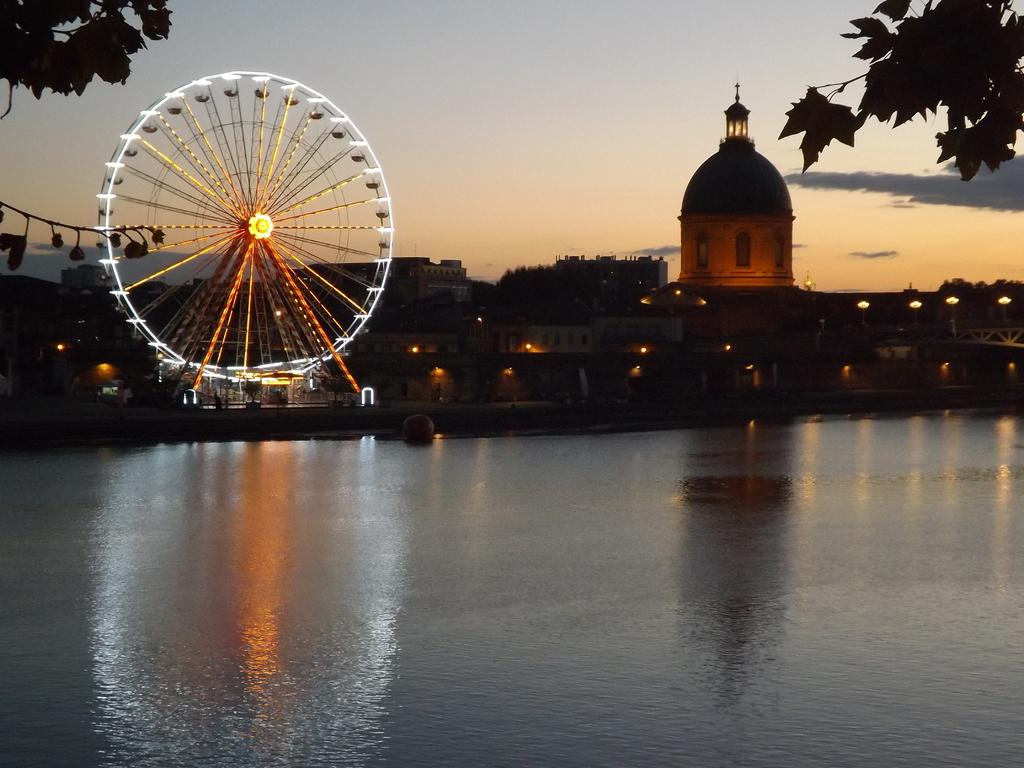What is the primary element visible in the image? There is water in the image. What structure can be seen on the left side of the image? There is a giant wheel on the left side of the image. What type of natural scenery is visible in the background of the image? There are trees in the background of the image. What type of artificial structures can be seen in the background of the image? There are buildings in the background of the image. What type of illumination is present in the background of the image? There are lights in the background of the image. What type of atmospheric conditions can be seen in the background of the image? There are clouds in the background of the image. How many clovers are floating on the water in the image? There are no clovers visible in the image; it features water, a giant wheel, and background elements. 